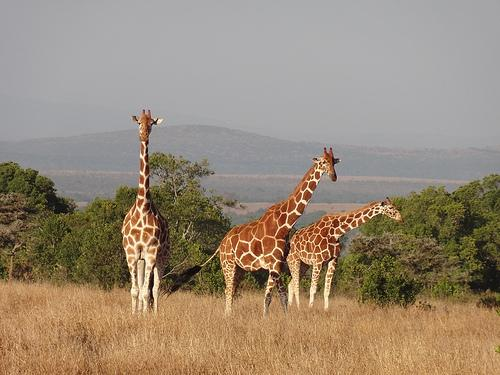Choose an animal in the image and describe its appearance. The front-view African giraffe has tan and brown coloration, distinctive spots, lowered-looking head, and a black tip on its tail. Identify the primary animals in the image and their activity. There are three African giraffes in the foreground, one is looking at the camera, one is eating tree leaves, and one is walking in the field. In detail, describe the positions of the three main animals in the image. One giraffe is on the left with its head facing forward, another is in the middle walking in the field, and the last one is on the right eating tree leaves. Mention the features of the sky and how it looks in the image. The sky is a mix of blue and grey, with patches of white clouds scattered across various portions of the image. Mention the color of the clouds in the sky and the location of the mountains related to the animals. The clouds are white, while the mountains are located behind the three giraffes in the background. Describe the overall scenery, including the weather and environmental conditions. The image shows a sunlit grassland with dry, tall brown grass, green trees, and white clouds in the blue-grey sky. Provide a description of the setting in which the giraffes are found. The giraffes are in a dry, brown grassland with thick bushes, tall trees in the background, and a small mountain in the distance. What do you notice about the grassland in which the giraffes are standing? The grassland is characterized by dried-out, tan-colored tall grass and thick bushes scattered throughout the area. Identify the trees in relation to the position of the giraffes in the image. The tall trees are located behind the giraffes and provide a backdrop for the animals in the image. Point out a distinct feature on one of the giraffes in the image. One giraffe in the image has a black hair on its tail and horns on its head. 